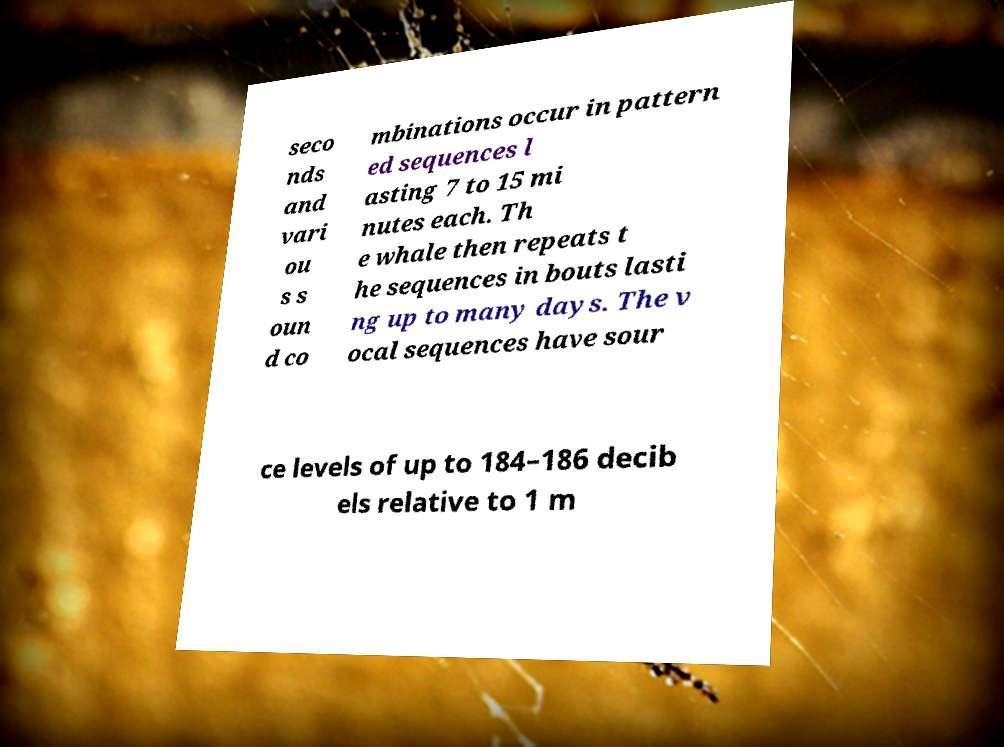Could you assist in decoding the text presented in this image and type it out clearly? seco nds and vari ou s s oun d co mbinations occur in pattern ed sequences l asting 7 to 15 mi nutes each. Th e whale then repeats t he sequences in bouts lasti ng up to many days. The v ocal sequences have sour ce levels of up to 184–186 decib els relative to 1 m 